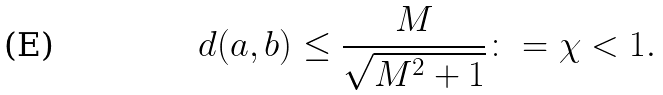Convert formula to latex. <formula><loc_0><loc_0><loc_500><loc_500>d ( a , b ) \leq \frac { M } { \sqrt { M ^ { 2 } + 1 } } \colon = \chi < 1 .</formula> 